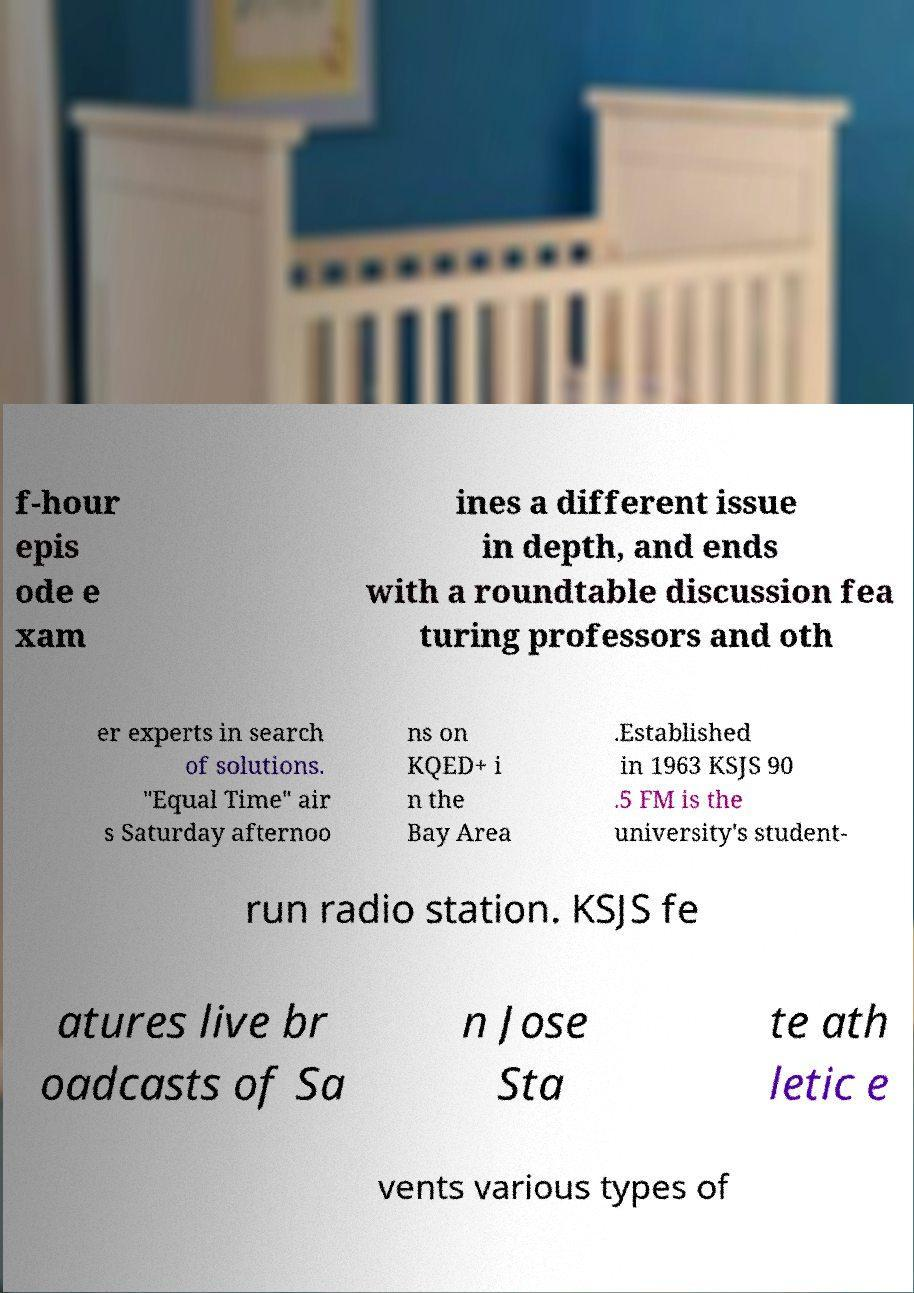Could you extract and type out the text from this image? f-hour epis ode e xam ines a different issue in depth, and ends with a roundtable discussion fea turing professors and oth er experts in search of solutions. "Equal Time" air s Saturday afternoo ns on KQED+ i n the Bay Area .Established in 1963 KSJS 90 .5 FM is the university's student- run radio station. KSJS fe atures live br oadcasts of Sa n Jose Sta te ath letic e vents various types of 